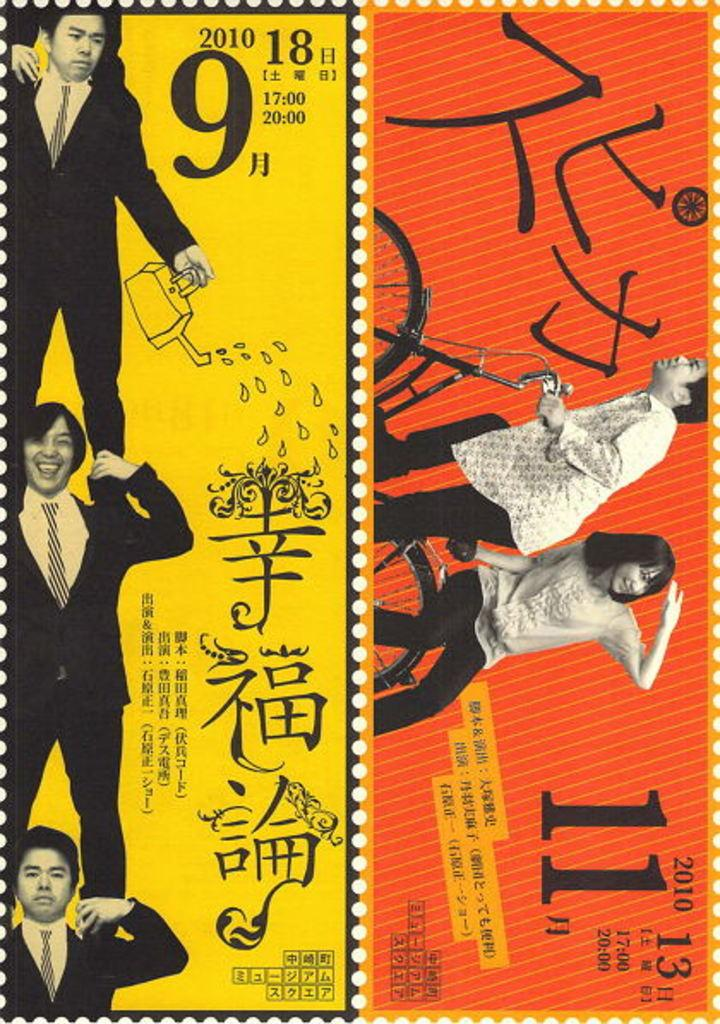<image>
Summarize the visual content of the image. A stamp of men standing on top of each other with 2010 written on it. 